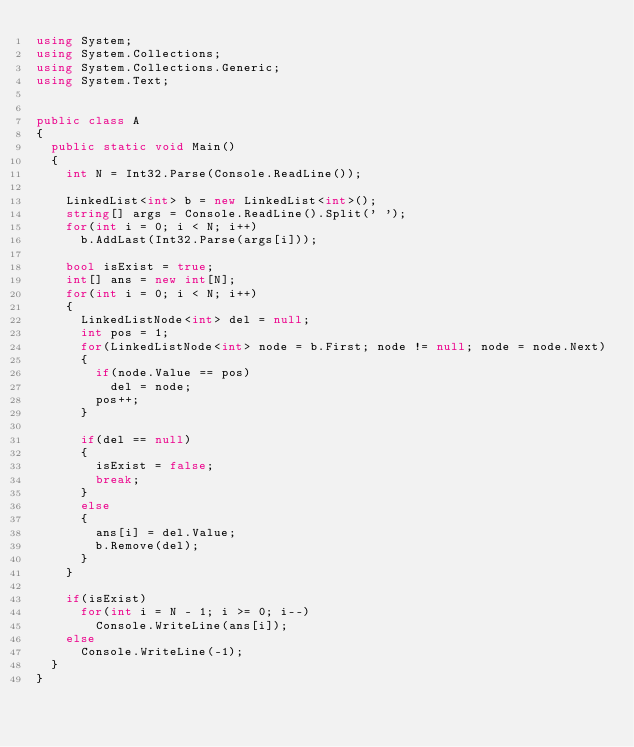<code> <loc_0><loc_0><loc_500><loc_500><_C#_>using System;
using System.Collections;
using System.Collections.Generic;
using System.Text;


public class A
{
	public static void Main()
	{
		int N = Int32.Parse(Console.ReadLine());

		LinkedList<int> b = new LinkedList<int>();
		string[] args = Console.ReadLine().Split(' ');
		for(int i = 0; i < N; i++)
			b.AddLast(Int32.Parse(args[i]));
		
		bool isExist = true;
		int[] ans = new int[N];
		for(int i = 0; i < N; i++)
		{
			LinkedListNode<int> del = null;
			int pos = 1;
			for(LinkedListNode<int> node = b.First; node != null; node = node.Next)
			{				
				if(node.Value == pos)
					del = node;
				pos++;
			}

			if(del == null)
			{
				isExist = false;
				break;
			}
			else
			{				
				ans[i] = del.Value;
				b.Remove(del);
			}
		}

		if(isExist)
			for(int i = N - 1; i >= 0; i--)
				Console.WriteLine(ans[i]);
		else
			Console.WriteLine(-1);
	}
}



</code> 